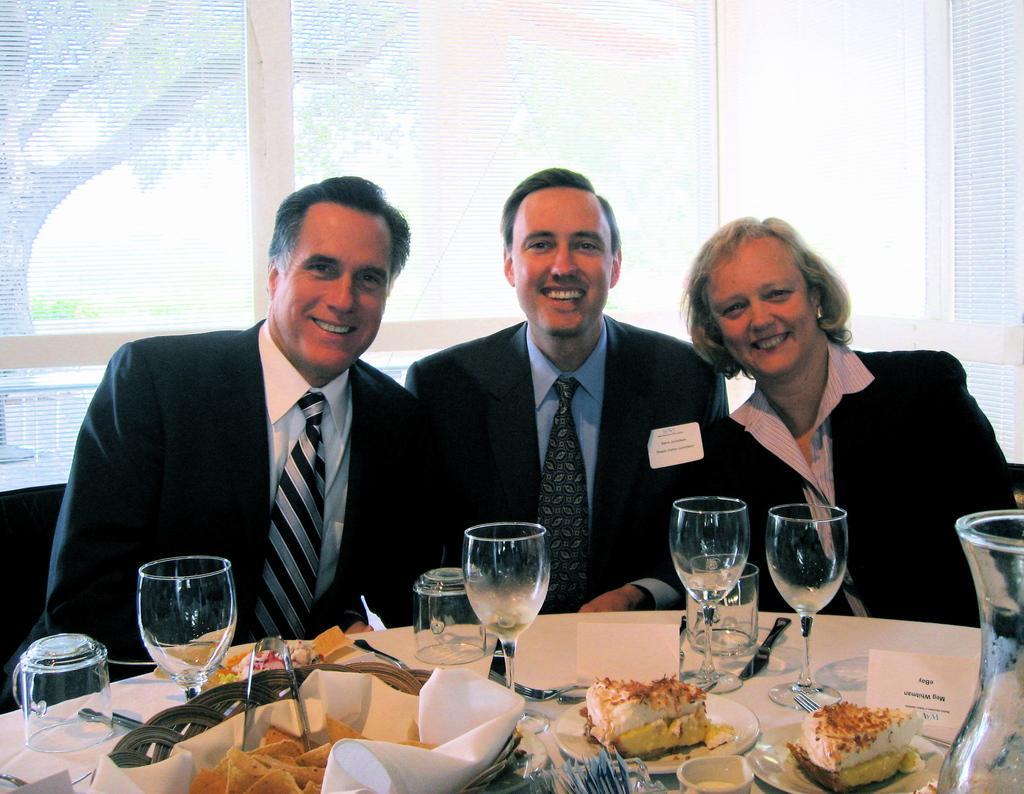How would you summarize this image in a sentence or two? We can see three persons sitting on chairs and they hold a smile on their faces. Here on the table we can see glasses, tissue papers, plate of food and a jar. On the background we can see window and trees are visible. 